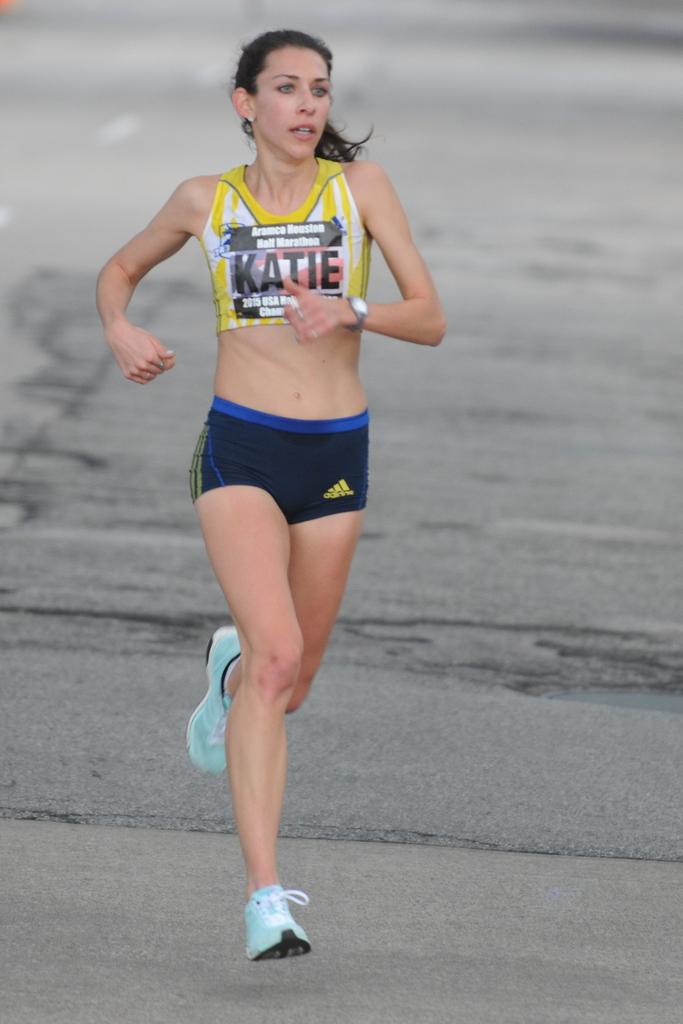What year is shown on the runner's bib?
Provide a short and direct response. 2015. 